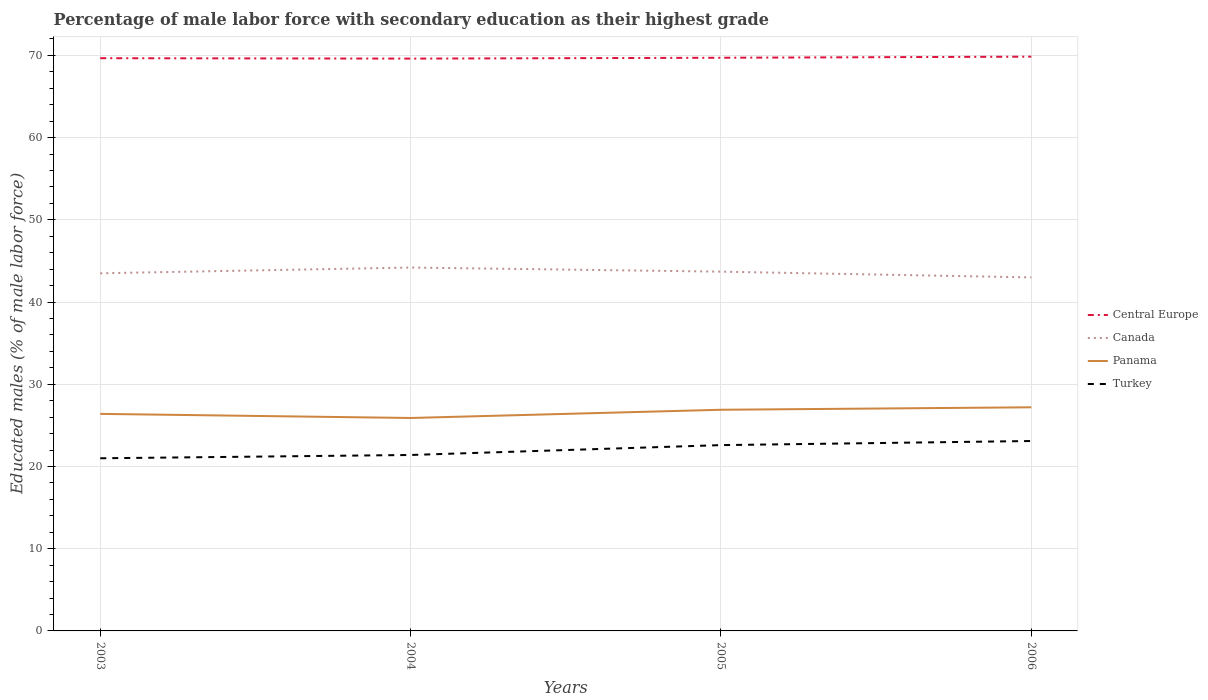How many different coloured lines are there?
Make the answer very short. 4. Does the line corresponding to Turkey intersect with the line corresponding to Central Europe?
Your response must be concise. No. What is the total percentage of male labor force with secondary education in Canada in the graph?
Provide a short and direct response. 0.7. What is the difference between the highest and the second highest percentage of male labor force with secondary education in Panama?
Ensure brevity in your answer.  1.3. How many lines are there?
Your answer should be very brief. 4. How many years are there in the graph?
Your response must be concise. 4. What is the difference between two consecutive major ticks on the Y-axis?
Offer a terse response. 10. Does the graph contain any zero values?
Keep it short and to the point. No. Where does the legend appear in the graph?
Provide a succinct answer. Center right. How many legend labels are there?
Keep it short and to the point. 4. How are the legend labels stacked?
Your answer should be compact. Vertical. What is the title of the graph?
Your answer should be very brief. Percentage of male labor force with secondary education as their highest grade. What is the label or title of the X-axis?
Keep it short and to the point. Years. What is the label or title of the Y-axis?
Provide a short and direct response. Educated males (% of male labor force). What is the Educated males (% of male labor force) of Central Europe in 2003?
Give a very brief answer. 69.66. What is the Educated males (% of male labor force) of Canada in 2003?
Offer a very short reply. 43.5. What is the Educated males (% of male labor force) in Panama in 2003?
Offer a very short reply. 26.4. What is the Educated males (% of male labor force) of Turkey in 2003?
Your answer should be compact. 21. What is the Educated males (% of male labor force) in Central Europe in 2004?
Offer a terse response. 69.61. What is the Educated males (% of male labor force) of Canada in 2004?
Provide a succinct answer. 44.2. What is the Educated males (% of male labor force) in Panama in 2004?
Give a very brief answer. 25.9. What is the Educated males (% of male labor force) in Turkey in 2004?
Your response must be concise. 21.4. What is the Educated males (% of male labor force) of Central Europe in 2005?
Keep it short and to the point. 69.72. What is the Educated males (% of male labor force) of Canada in 2005?
Keep it short and to the point. 43.7. What is the Educated males (% of male labor force) of Panama in 2005?
Your answer should be compact. 26.9. What is the Educated males (% of male labor force) in Turkey in 2005?
Offer a terse response. 22.6. What is the Educated males (% of male labor force) of Central Europe in 2006?
Your response must be concise. 69.85. What is the Educated males (% of male labor force) in Panama in 2006?
Your response must be concise. 27.2. What is the Educated males (% of male labor force) of Turkey in 2006?
Provide a succinct answer. 23.1. Across all years, what is the maximum Educated males (% of male labor force) of Central Europe?
Provide a succinct answer. 69.85. Across all years, what is the maximum Educated males (% of male labor force) of Canada?
Ensure brevity in your answer.  44.2. Across all years, what is the maximum Educated males (% of male labor force) of Panama?
Your answer should be compact. 27.2. Across all years, what is the maximum Educated males (% of male labor force) in Turkey?
Provide a succinct answer. 23.1. Across all years, what is the minimum Educated males (% of male labor force) in Central Europe?
Make the answer very short. 69.61. Across all years, what is the minimum Educated males (% of male labor force) in Canada?
Provide a short and direct response. 43. Across all years, what is the minimum Educated males (% of male labor force) in Panama?
Ensure brevity in your answer.  25.9. What is the total Educated males (% of male labor force) in Central Europe in the graph?
Keep it short and to the point. 278.84. What is the total Educated males (% of male labor force) of Canada in the graph?
Your answer should be very brief. 174.4. What is the total Educated males (% of male labor force) in Panama in the graph?
Your answer should be very brief. 106.4. What is the total Educated males (% of male labor force) of Turkey in the graph?
Your response must be concise. 88.1. What is the difference between the Educated males (% of male labor force) of Canada in 2003 and that in 2004?
Keep it short and to the point. -0.7. What is the difference between the Educated males (% of male labor force) of Panama in 2003 and that in 2004?
Your response must be concise. 0.5. What is the difference between the Educated males (% of male labor force) in Central Europe in 2003 and that in 2005?
Provide a succinct answer. -0.05. What is the difference between the Educated males (% of male labor force) in Panama in 2003 and that in 2005?
Your response must be concise. -0.5. What is the difference between the Educated males (% of male labor force) in Turkey in 2003 and that in 2005?
Keep it short and to the point. -1.6. What is the difference between the Educated males (% of male labor force) of Central Europe in 2003 and that in 2006?
Provide a succinct answer. -0.19. What is the difference between the Educated males (% of male labor force) in Panama in 2003 and that in 2006?
Your answer should be very brief. -0.8. What is the difference between the Educated males (% of male labor force) of Central Europe in 2004 and that in 2005?
Provide a short and direct response. -0.1. What is the difference between the Educated males (% of male labor force) in Canada in 2004 and that in 2005?
Offer a very short reply. 0.5. What is the difference between the Educated males (% of male labor force) of Central Europe in 2004 and that in 2006?
Offer a very short reply. -0.24. What is the difference between the Educated males (% of male labor force) in Canada in 2004 and that in 2006?
Offer a very short reply. 1.2. What is the difference between the Educated males (% of male labor force) in Panama in 2004 and that in 2006?
Ensure brevity in your answer.  -1.3. What is the difference between the Educated males (% of male labor force) of Turkey in 2004 and that in 2006?
Give a very brief answer. -1.7. What is the difference between the Educated males (% of male labor force) in Central Europe in 2005 and that in 2006?
Make the answer very short. -0.13. What is the difference between the Educated males (% of male labor force) in Canada in 2005 and that in 2006?
Make the answer very short. 0.7. What is the difference between the Educated males (% of male labor force) in Panama in 2005 and that in 2006?
Offer a terse response. -0.3. What is the difference between the Educated males (% of male labor force) of Central Europe in 2003 and the Educated males (% of male labor force) of Canada in 2004?
Your answer should be very brief. 25.46. What is the difference between the Educated males (% of male labor force) in Central Europe in 2003 and the Educated males (% of male labor force) in Panama in 2004?
Make the answer very short. 43.76. What is the difference between the Educated males (% of male labor force) in Central Europe in 2003 and the Educated males (% of male labor force) in Turkey in 2004?
Keep it short and to the point. 48.26. What is the difference between the Educated males (% of male labor force) of Canada in 2003 and the Educated males (% of male labor force) of Panama in 2004?
Keep it short and to the point. 17.6. What is the difference between the Educated males (% of male labor force) in Canada in 2003 and the Educated males (% of male labor force) in Turkey in 2004?
Offer a terse response. 22.1. What is the difference between the Educated males (% of male labor force) of Central Europe in 2003 and the Educated males (% of male labor force) of Canada in 2005?
Provide a short and direct response. 25.96. What is the difference between the Educated males (% of male labor force) of Central Europe in 2003 and the Educated males (% of male labor force) of Panama in 2005?
Keep it short and to the point. 42.76. What is the difference between the Educated males (% of male labor force) in Central Europe in 2003 and the Educated males (% of male labor force) in Turkey in 2005?
Make the answer very short. 47.06. What is the difference between the Educated males (% of male labor force) in Canada in 2003 and the Educated males (% of male labor force) in Turkey in 2005?
Provide a short and direct response. 20.9. What is the difference between the Educated males (% of male labor force) of Central Europe in 2003 and the Educated males (% of male labor force) of Canada in 2006?
Provide a short and direct response. 26.66. What is the difference between the Educated males (% of male labor force) in Central Europe in 2003 and the Educated males (% of male labor force) in Panama in 2006?
Your answer should be compact. 42.46. What is the difference between the Educated males (% of male labor force) of Central Europe in 2003 and the Educated males (% of male labor force) of Turkey in 2006?
Your answer should be compact. 46.56. What is the difference between the Educated males (% of male labor force) of Canada in 2003 and the Educated males (% of male labor force) of Panama in 2006?
Make the answer very short. 16.3. What is the difference between the Educated males (% of male labor force) in Canada in 2003 and the Educated males (% of male labor force) in Turkey in 2006?
Keep it short and to the point. 20.4. What is the difference between the Educated males (% of male labor force) in Panama in 2003 and the Educated males (% of male labor force) in Turkey in 2006?
Make the answer very short. 3.3. What is the difference between the Educated males (% of male labor force) of Central Europe in 2004 and the Educated males (% of male labor force) of Canada in 2005?
Keep it short and to the point. 25.91. What is the difference between the Educated males (% of male labor force) in Central Europe in 2004 and the Educated males (% of male labor force) in Panama in 2005?
Give a very brief answer. 42.71. What is the difference between the Educated males (% of male labor force) in Central Europe in 2004 and the Educated males (% of male labor force) in Turkey in 2005?
Keep it short and to the point. 47.01. What is the difference between the Educated males (% of male labor force) in Canada in 2004 and the Educated males (% of male labor force) in Turkey in 2005?
Make the answer very short. 21.6. What is the difference between the Educated males (% of male labor force) of Central Europe in 2004 and the Educated males (% of male labor force) of Canada in 2006?
Your answer should be compact. 26.61. What is the difference between the Educated males (% of male labor force) in Central Europe in 2004 and the Educated males (% of male labor force) in Panama in 2006?
Your answer should be very brief. 42.41. What is the difference between the Educated males (% of male labor force) of Central Europe in 2004 and the Educated males (% of male labor force) of Turkey in 2006?
Provide a succinct answer. 46.51. What is the difference between the Educated males (% of male labor force) of Canada in 2004 and the Educated males (% of male labor force) of Turkey in 2006?
Offer a very short reply. 21.1. What is the difference between the Educated males (% of male labor force) in Central Europe in 2005 and the Educated males (% of male labor force) in Canada in 2006?
Provide a short and direct response. 26.72. What is the difference between the Educated males (% of male labor force) of Central Europe in 2005 and the Educated males (% of male labor force) of Panama in 2006?
Offer a terse response. 42.52. What is the difference between the Educated males (% of male labor force) in Central Europe in 2005 and the Educated males (% of male labor force) in Turkey in 2006?
Offer a very short reply. 46.62. What is the difference between the Educated males (% of male labor force) of Canada in 2005 and the Educated males (% of male labor force) of Panama in 2006?
Your answer should be compact. 16.5. What is the difference between the Educated males (% of male labor force) of Canada in 2005 and the Educated males (% of male labor force) of Turkey in 2006?
Provide a succinct answer. 20.6. What is the difference between the Educated males (% of male labor force) of Panama in 2005 and the Educated males (% of male labor force) of Turkey in 2006?
Your answer should be very brief. 3.8. What is the average Educated males (% of male labor force) of Central Europe per year?
Offer a very short reply. 69.71. What is the average Educated males (% of male labor force) of Canada per year?
Offer a very short reply. 43.6. What is the average Educated males (% of male labor force) in Panama per year?
Keep it short and to the point. 26.6. What is the average Educated males (% of male labor force) of Turkey per year?
Your response must be concise. 22.02. In the year 2003, what is the difference between the Educated males (% of male labor force) in Central Europe and Educated males (% of male labor force) in Canada?
Your response must be concise. 26.16. In the year 2003, what is the difference between the Educated males (% of male labor force) in Central Europe and Educated males (% of male labor force) in Panama?
Provide a short and direct response. 43.26. In the year 2003, what is the difference between the Educated males (% of male labor force) of Central Europe and Educated males (% of male labor force) of Turkey?
Your answer should be compact. 48.66. In the year 2003, what is the difference between the Educated males (% of male labor force) in Canada and Educated males (% of male labor force) in Panama?
Your answer should be very brief. 17.1. In the year 2003, what is the difference between the Educated males (% of male labor force) in Canada and Educated males (% of male labor force) in Turkey?
Keep it short and to the point. 22.5. In the year 2004, what is the difference between the Educated males (% of male labor force) of Central Europe and Educated males (% of male labor force) of Canada?
Provide a short and direct response. 25.41. In the year 2004, what is the difference between the Educated males (% of male labor force) of Central Europe and Educated males (% of male labor force) of Panama?
Give a very brief answer. 43.71. In the year 2004, what is the difference between the Educated males (% of male labor force) in Central Europe and Educated males (% of male labor force) in Turkey?
Ensure brevity in your answer.  48.21. In the year 2004, what is the difference between the Educated males (% of male labor force) of Canada and Educated males (% of male labor force) of Turkey?
Give a very brief answer. 22.8. In the year 2004, what is the difference between the Educated males (% of male labor force) of Panama and Educated males (% of male labor force) of Turkey?
Provide a short and direct response. 4.5. In the year 2005, what is the difference between the Educated males (% of male labor force) of Central Europe and Educated males (% of male labor force) of Canada?
Provide a succinct answer. 26.02. In the year 2005, what is the difference between the Educated males (% of male labor force) of Central Europe and Educated males (% of male labor force) of Panama?
Provide a succinct answer. 42.82. In the year 2005, what is the difference between the Educated males (% of male labor force) of Central Europe and Educated males (% of male labor force) of Turkey?
Offer a very short reply. 47.12. In the year 2005, what is the difference between the Educated males (% of male labor force) of Canada and Educated males (% of male labor force) of Turkey?
Your response must be concise. 21.1. In the year 2005, what is the difference between the Educated males (% of male labor force) of Panama and Educated males (% of male labor force) of Turkey?
Offer a terse response. 4.3. In the year 2006, what is the difference between the Educated males (% of male labor force) of Central Europe and Educated males (% of male labor force) of Canada?
Provide a succinct answer. 26.85. In the year 2006, what is the difference between the Educated males (% of male labor force) in Central Europe and Educated males (% of male labor force) in Panama?
Provide a short and direct response. 42.65. In the year 2006, what is the difference between the Educated males (% of male labor force) in Central Europe and Educated males (% of male labor force) in Turkey?
Give a very brief answer. 46.75. In the year 2006, what is the difference between the Educated males (% of male labor force) of Panama and Educated males (% of male labor force) of Turkey?
Give a very brief answer. 4.1. What is the ratio of the Educated males (% of male labor force) in Canada in 2003 to that in 2004?
Your response must be concise. 0.98. What is the ratio of the Educated males (% of male labor force) in Panama in 2003 to that in 2004?
Your answer should be very brief. 1.02. What is the ratio of the Educated males (% of male labor force) in Turkey in 2003 to that in 2004?
Offer a very short reply. 0.98. What is the ratio of the Educated males (% of male labor force) of Central Europe in 2003 to that in 2005?
Your response must be concise. 1. What is the ratio of the Educated males (% of male labor force) in Canada in 2003 to that in 2005?
Your answer should be compact. 1. What is the ratio of the Educated males (% of male labor force) in Panama in 2003 to that in 2005?
Give a very brief answer. 0.98. What is the ratio of the Educated males (% of male labor force) in Turkey in 2003 to that in 2005?
Provide a succinct answer. 0.93. What is the ratio of the Educated males (% of male labor force) in Central Europe in 2003 to that in 2006?
Offer a very short reply. 1. What is the ratio of the Educated males (% of male labor force) in Canada in 2003 to that in 2006?
Give a very brief answer. 1.01. What is the ratio of the Educated males (% of male labor force) of Panama in 2003 to that in 2006?
Offer a terse response. 0.97. What is the ratio of the Educated males (% of male labor force) in Canada in 2004 to that in 2005?
Your answer should be compact. 1.01. What is the ratio of the Educated males (% of male labor force) in Panama in 2004 to that in 2005?
Your answer should be compact. 0.96. What is the ratio of the Educated males (% of male labor force) of Turkey in 2004 to that in 2005?
Your response must be concise. 0.95. What is the ratio of the Educated males (% of male labor force) in Canada in 2004 to that in 2006?
Give a very brief answer. 1.03. What is the ratio of the Educated males (% of male labor force) in Panama in 2004 to that in 2006?
Your answer should be compact. 0.95. What is the ratio of the Educated males (% of male labor force) of Turkey in 2004 to that in 2006?
Your response must be concise. 0.93. What is the ratio of the Educated males (% of male labor force) in Canada in 2005 to that in 2006?
Provide a succinct answer. 1.02. What is the ratio of the Educated males (% of male labor force) of Panama in 2005 to that in 2006?
Provide a succinct answer. 0.99. What is the ratio of the Educated males (% of male labor force) of Turkey in 2005 to that in 2006?
Keep it short and to the point. 0.98. What is the difference between the highest and the second highest Educated males (% of male labor force) of Central Europe?
Make the answer very short. 0.13. What is the difference between the highest and the second highest Educated males (% of male labor force) in Canada?
Your answer should be compact. 0.5. What is the difference between the highest and the second highest Educated males (% of male labor force) in Turkey?
Ensure brevity in your answer.  0.5. What is the difference between the highest and the lowest Educated males (% of male labor force) of Central Europe?
Offer a very short reply. 0.24. What is the difference between the highest and the lowest Educated males (% of male labor force) of Canada?
Give a very brief answer. 1.2. What is the difference between the highest and the lowest Educated males (% of male labor force) in Panama?
Your response must be concise. 1.3. What is the difference between the highest and the lowest Educated males (% of male labor force) of Turkey?
Your answer should be very brief. 2.1. 